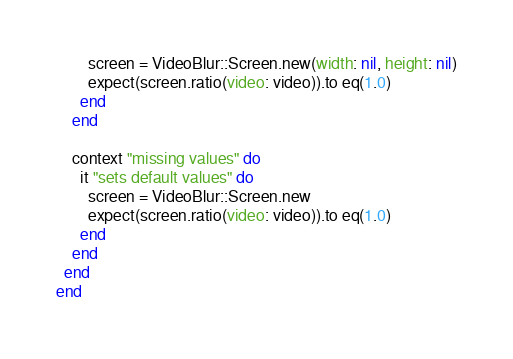Convert code to text. <code><loc_0><loc_0><loc_500><loc_500><_Ruby_>        screen = VideoBlur::Screen.new(width: nil, height: nil)
        expect(screen.ratio(video: video)).to eq(1.0)
      end
    end
    
    context "missing values" do
      it "sets default values" do
        screen = VideoBlur::Screen.new
        expect(screen.ratio(video: video)).to eq(1.0)
      end
    end
  end
end</code> 